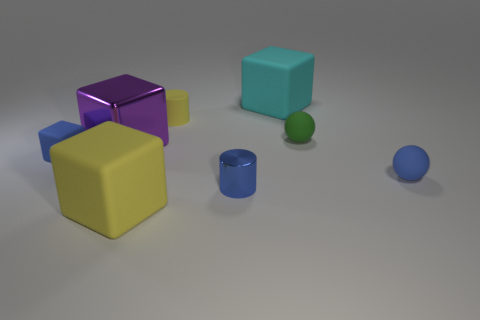What color is the shiny cylinder?
Provide a short and direct response. Blue. There is a tiny blue thing on the right side of the large cyan matte thing; what is its material?
Your response must be concise. Rubber. The cyan rubber thing that is the same shape as the purple shiny thing is what size?
Your answer should be compact. Large. Is the number of large metallic objects behind the tiny green matte object less than the number of red metal balls?
Provide a succinct answer. No. Are there any small blue matte blocks?
Provide a short and direct response. Yes. There is a rubber thing that is the same shape as the small metallic thing; what is its color?
Your answer should be compact. Yellow. Do the matte sphere in front of the blue matte block and the metallic cylinder have the same color?
Offer a terse response. Yes. Do the yellow rubber cylinder and the blue matte cube have the same size?
Provide a succinct answer. Yes. There is a big cyan object that is the same material as the green thing; what is its shape?
Ensure brevity in your answer.  Cube. How many other objects are the same shape as the cyan object?
Provide a succinct answer. 3. 